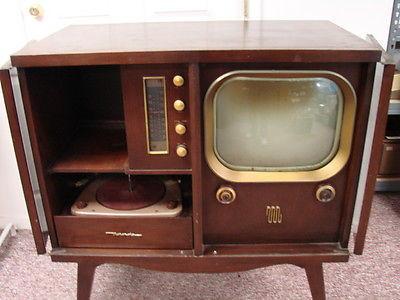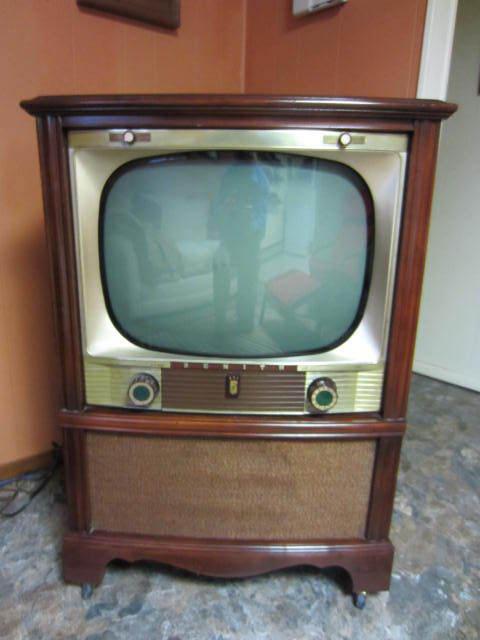The first image is the image on the left, the second image is the image on the right. Analyze the images presented: Is the assertion "An image shows an old-fashioned wood-cased TV set with an oblong screen, elevated with slender tapered wood legs." valid? Answer yes or no. Yes. 